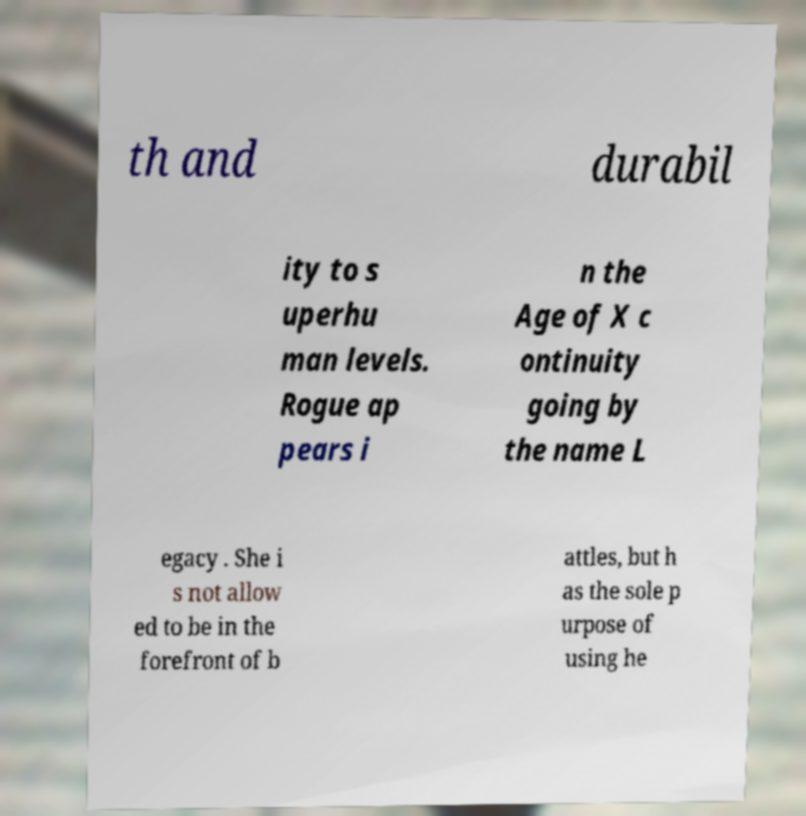I need the written content from this picture converted into text. Can you do that? th and durabil ity to s uperhu man levels. Rogue ap pears i n the Age of X c ontinuity going by the name L egacy . She i s not allow ed to be in the forefront of b attles, but h as the sole p urpose of using he 